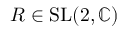<formula> <loc_0><loc_0><loc_500><loc_500>R \in S L ( 2 , \mathbb { C } )</formula> 